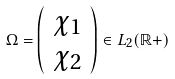Convert formula to latex. <formula><loc_0><loc_0><loc_500><loc_500>\Omega = \left ( \begin{array} { c } \chi _ { 1 } \\ \chi _ { 2 } \end{array} \right ) \in L _ { 2 } ( \mathbb { R ^ { + } } )</formula> 